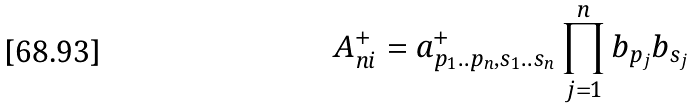Convert formula to latex. <formula><loc_0><loc_0><loc_500><loc_500>A ^ { + } _ { n i } = a ^ { + } _ { p _ { 1 } . . p _ { n } , s _ { 1 } . . s _ { n } } \prod _ { j = 1 } ^ { n } b _ { p _ { j } } b _ { s _ { j } }</formula> 